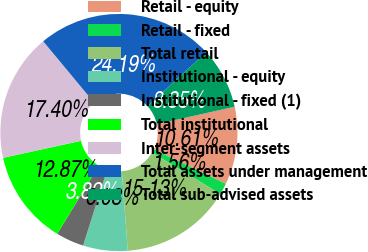<chart> <loc_0><loc_0><loc_500><loc_500><pie_chart><fcel>Retail - equity<fcel>Retail - fixed<fcel>Total retail<fcel>Institutional - equity<fcel>Institutional - fixed (1)<fcel>Total institutional<fcel>Inter-segment assets<fcel>Total assets under management<fcel>Total sub-advised assets<nl><fcel>10.61%<fcel>1.56%<fcel>15.13%<fcel>6.08%<fcel>3.82%<fcel>12.87%<fcel>17.4%<fcel>24.19%<fcel>8.35%<nl></chart> 